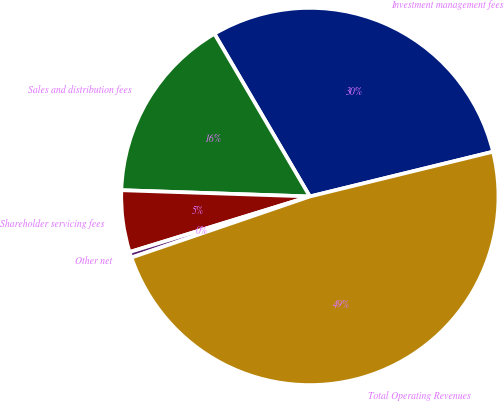Convert chart. <chart><loc_0><loc_0><loc_500><loc_500><pie_chart><fcel>Investment management fees<fcel>Sales and distribution fees<fcel>Shareholder servicing fees<fcel>Other net<fcel>Total Operating Revenues<nl><fcel>29.63%<fcel>16.03%<fcel>5.29%<fcel>0.49%<fcel>48.57%<nl></chart> 